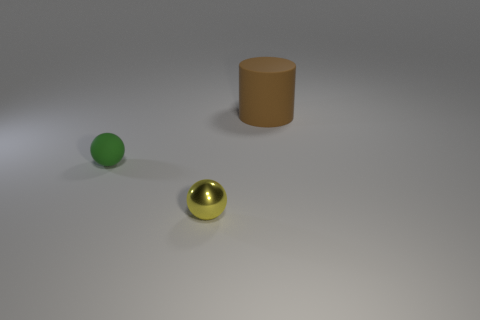There is a rubber object to the right of the small sphere that is in front of the small rubber ball; what shape is it?
Keep it short and to the point. Cylinder. What number of brown rubber things are behind the metal ball?
Your answer should be compact. 1. Does the green sphere have the same material as the sphere that is in front of the green ball?
Offer a terse response. No. Are there any brown rubber objects of the same size as the yellow thing?
Give a very brief answer. No. Are there the same number of brown cylinders that are in front of the yellow shiny object and green objects?
Provide a short and direct response. No. What is the size of the brown cylinder?
Your response must be concise. Large. There is a small thing that is behind the small yellow ball; what number of yellow objects are in front of it?
Offer a very short reply. 1. There is a object that is to the left of the large cylinder and on the right side of the small green sphere; what is its shape?
Ensure brevity in your answer.  Sphere. Is there a small matte thing that is in front of the small ball right of the ball to the left of the yellow thing?
Make the answer very short. No. There is a object that is both right of the tiny green thing and to the left of the big brown thing; what size is it?
Give a very brief answer. Small. 